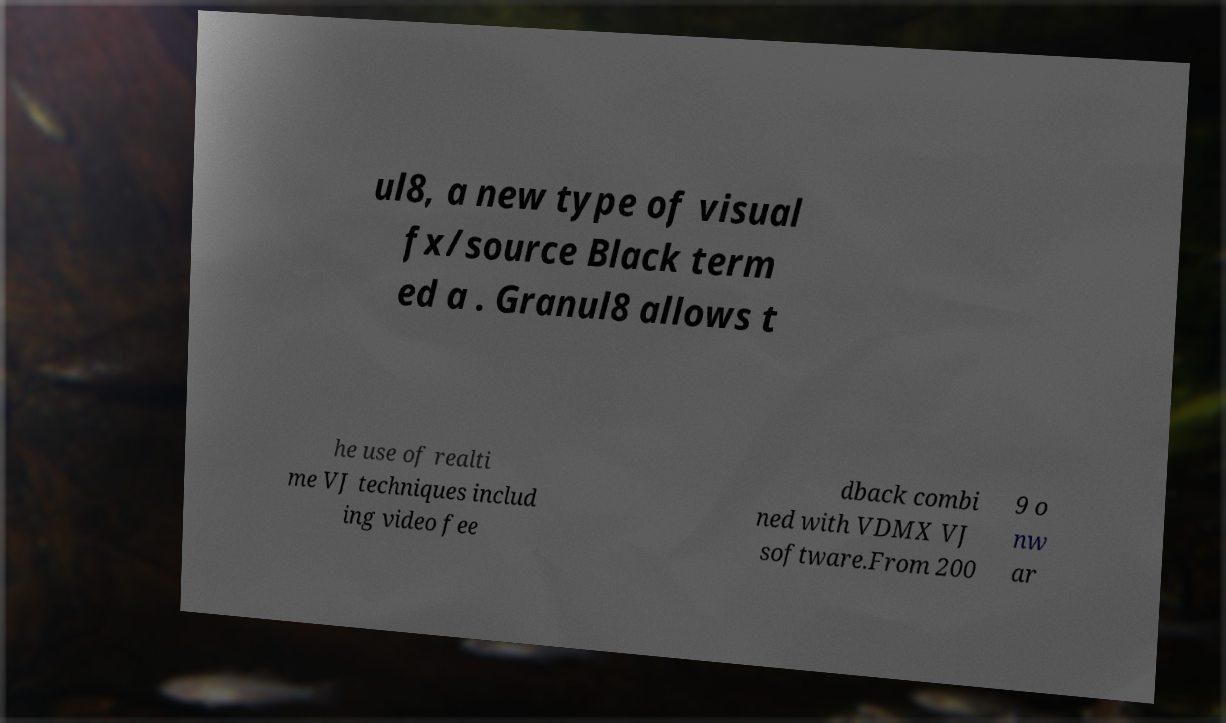Please read and relay the text visible in this image. What does it say? ul8, a new type of visual fx/source Black term ed a . Granul8 allows t he use of realti me VJ techniques includ ing video fee dback combi ned with VDMX VJ software.From 200 9 o nw ar 